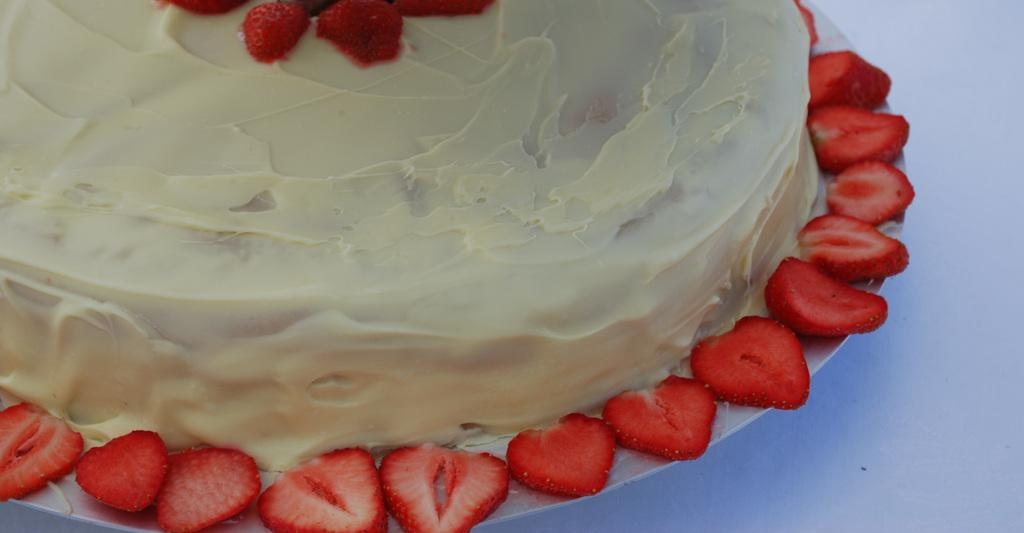What is the main food item featured in the image? There is a cake in the image. What type of fruit is present on the plate and the cake? There are strawberry slices on the plate and the cake. Is there any furniture or surface visible in the image? There might be a table at the bottom of the image. How many pies are stacked on top of the cake in the image? There are no pies present in the image; it only features a cake with strawberry slices. Can you see a rifle leaning against the table in the image? There is no rifle present in the image. 